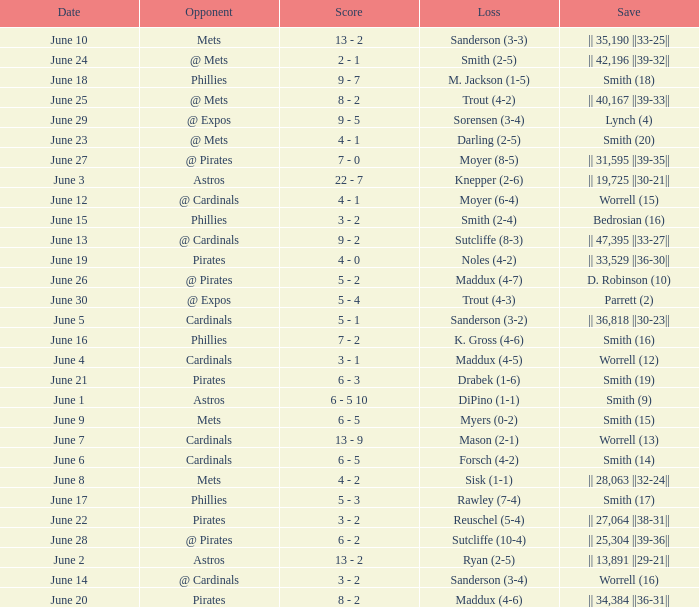The game that has a save of lynch (4) ended with what score? 9 - 5. 